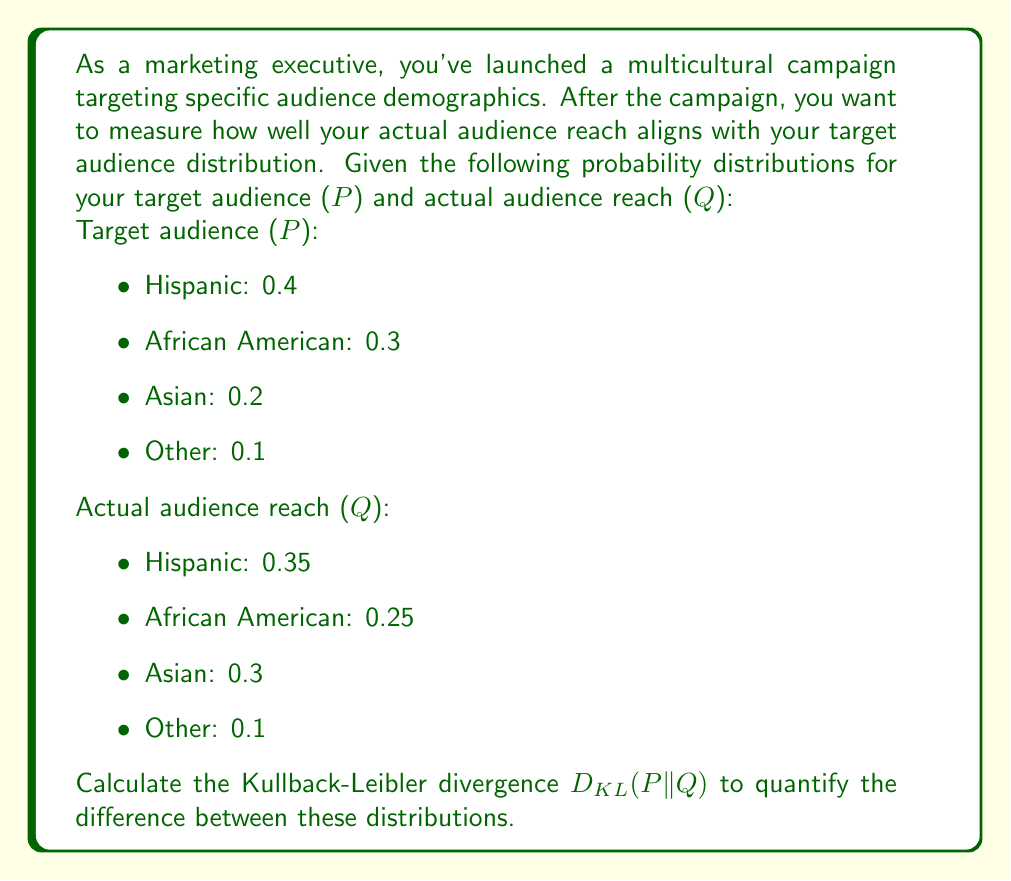Solve this math problem. To calculate the Kullback-Leibler (KL) divergence between the target audience distribution $P$ and the actual audience reach distribution $Q$, we use the following formula:

$$D_{KL}(P||Q) = \sum_{i} P(i) \log\left(\frac{P(i)}{Q(i)}\right)$$

Where $i$ represents each category in the distribution.

Let's calculate this step-by-step:

1) For Hispanic audience:
   $P(Hispanic) = 0.4$, $Q(Hispanic) = 0.35$
   $0.4 \log\left(\frac{0.4}{0.35}\right) = 0.4 \log(1.1429) = 0.0217$

2) For African American audience:
   $P(African American) = 0.3$, $Q(African American) = 0.25$
   $0.3 \log\left(\frac{0.3}{0.25}\right) = 0.3 \log(1.2) = 0.0547$

3) For Asian audience:
   $P(Asian) = 0.2$, $Q(Asian) = 0.3$
   $0.2 \log\left(\frac{0.2}{0.3}\right) = 0.2 \log(0.6667) = -0.0811$

4) For Other audience:
   $P(Other) = 0.1$, $Q(Other) = 0.1$
   $0.1 \log\left(\frac{0.1}{0.1}\right) = 0.1 \log(1) = 0$

Now, we sum all these values:

$$D_{KL}(P||Q) = 0.0217 + 0.0547 - 0.0811 + 0 = -0.0047$$

The negative result indicates that the actual distribution $Q$ is more spread out (has higher entropy) than the target distribution $P$.
Answer: $D_{KL}(P||Q) = -0.0047$ bits 